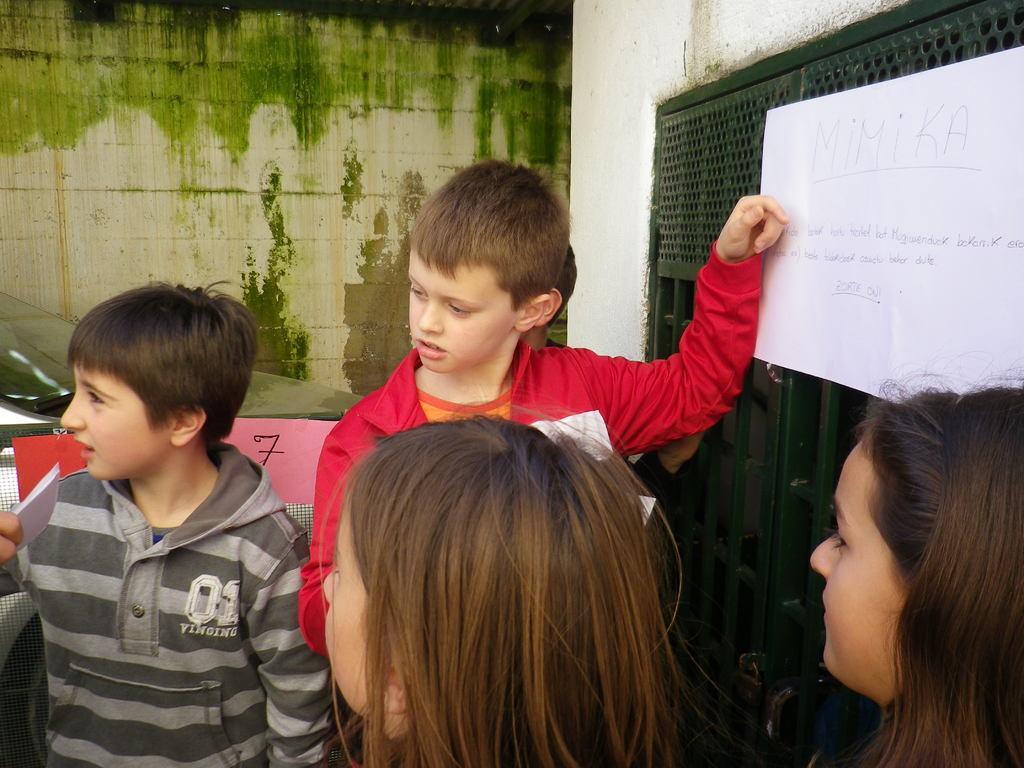Could you give a brief overview of what you see in this image? In this picture, we see five children are standing. The boy on the left side is holding a paper in his hand. On the right side, we see a paper with some text written is placed on the green door. Beside that, we see a white wall. Behind them, we see a fence and a car is parked on the road. Behind that, we see a wall in white and green color. 